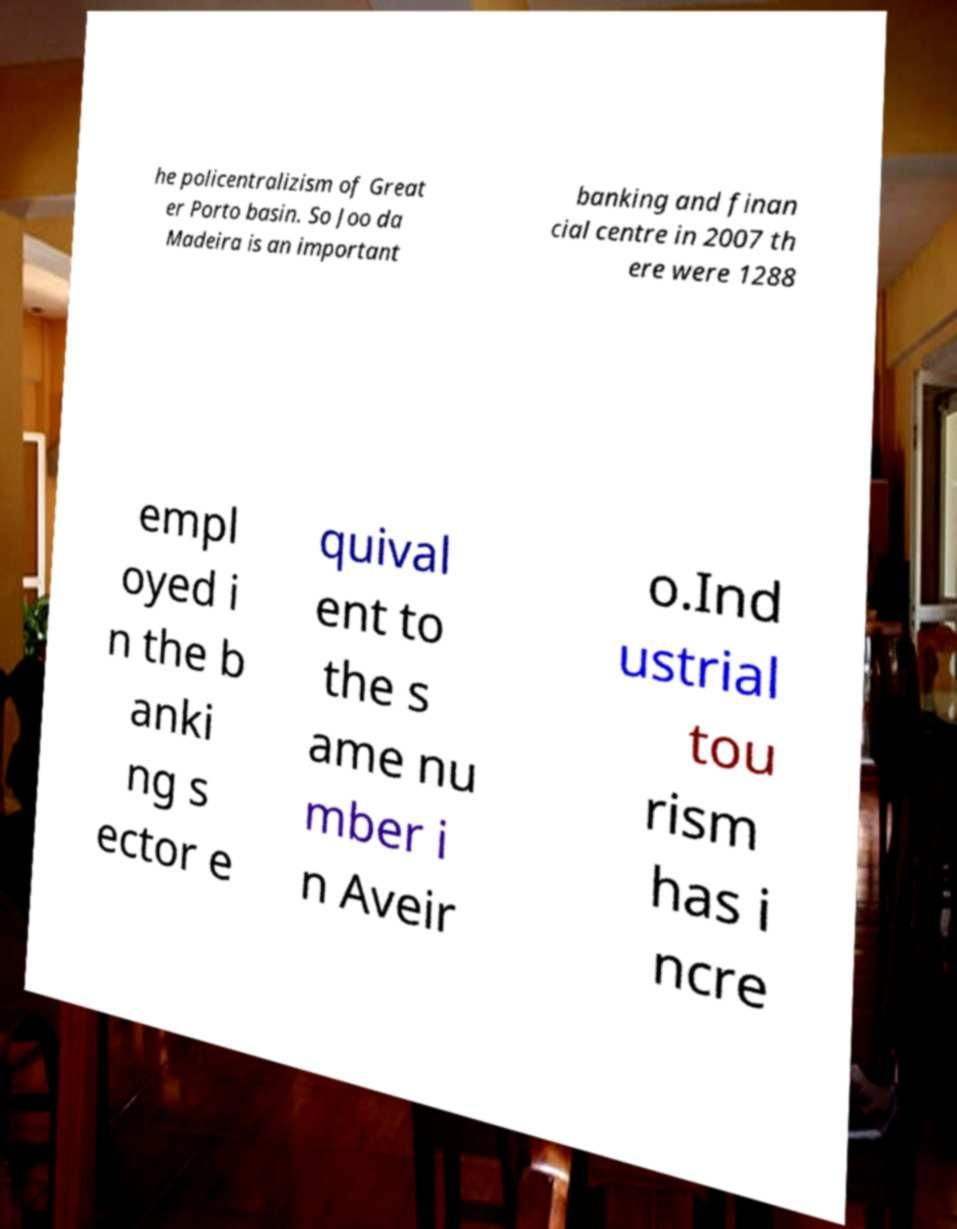Please read and relay the text visible in this image. What does it say? he policentralizism of Great er Porto basin. So Joo da Madeira is an important banking and finan cial centre in 2007 th ere were 1288 empl oyed i n the b anki ng s ector e quival ent to the s ame nu mber i n Aveir o.Ind ustrial tou rism has i ncre 